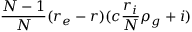<formula> <loc_0><loc_0><loc_500><loc_500>\frac { N - 1 } { N } ( r _ { e } - r ) ( c \frac { r _ { i } } { N } \rho _ { g } + i )</formula> 